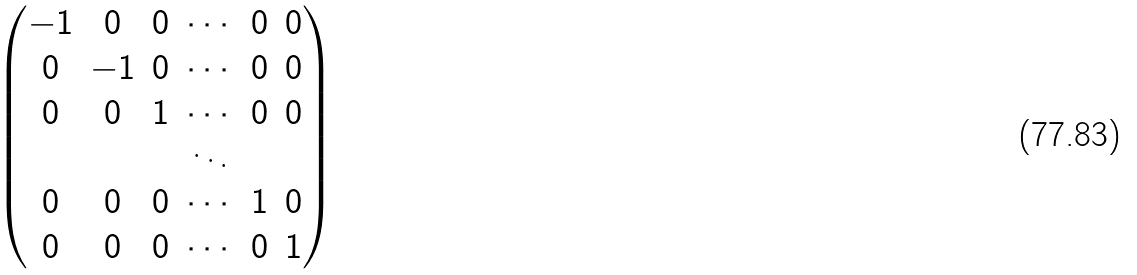<formula> <loc_0><loc_0><loc_500><loc_500>\begin{pmatrix} - 1 & 0 & 0 & \cdots & 0 & 0 \\ 0 & - 1 & 0 & \cdots & 0 & 0 \\ 0 & 0 & 1 & \cdots & 0 & 0 \\ & & & \ddots & & \\ 0 & 0 & 0 & \cdots & 1 & 0 \\ 0 & 0 & 0 & \cdots & 0 & 1 \\ \end{pmatrix}</formula> 